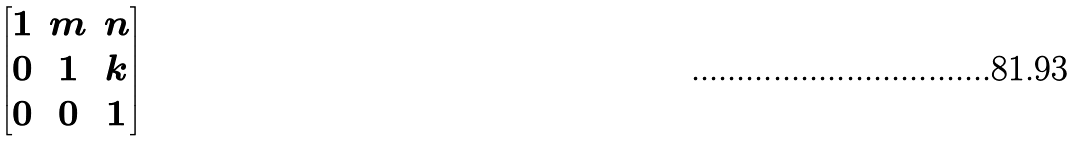<formula> <loc_0><loc_0><loc_500><loc_500>\begin{bmatrix} 1 & m & n \\ 0 & 1 & k \\ 0 & 0 & 1 \end{bmatrix}</formula> 